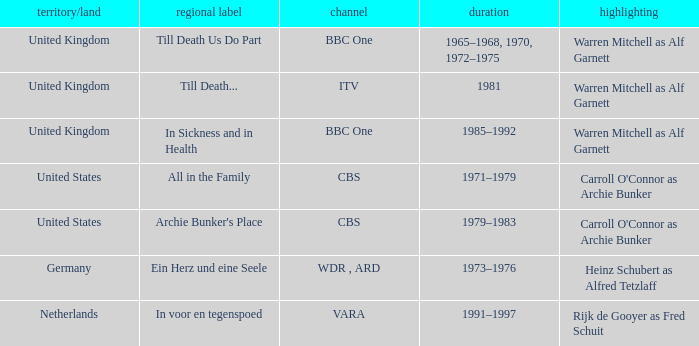Who was the star for the Vara network? Rijk de Gooyer as Fred Schuit. 